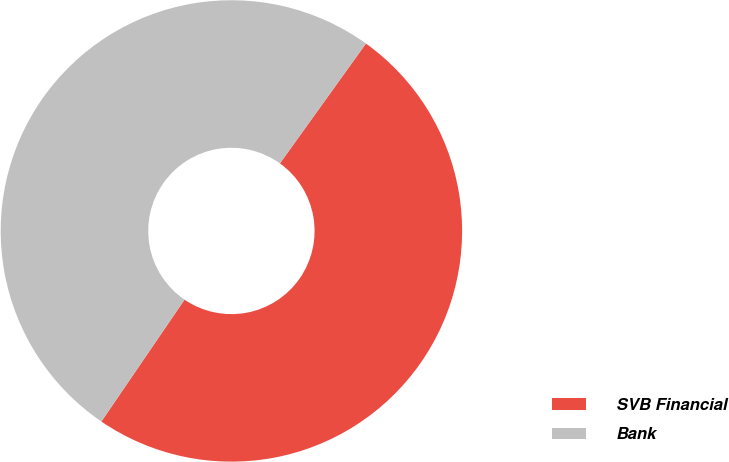Convert chart to OTSL. <chart><loc_0><loc_0><loc_500><loc_500><pie_chart><fcel>SVB Financial<fcel>Bank<nl><fcel>49.62%<fcel>50.38%<nl></chart> 